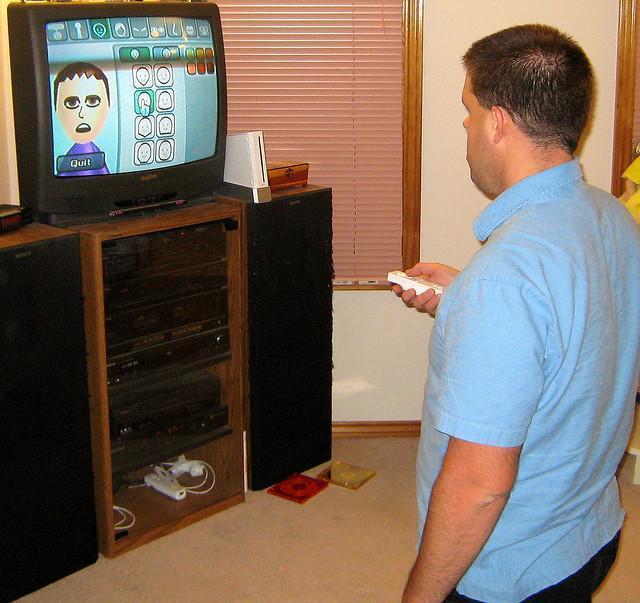How many airplanes have a vehicle under their wing?
Give a very brief answer. 0. 